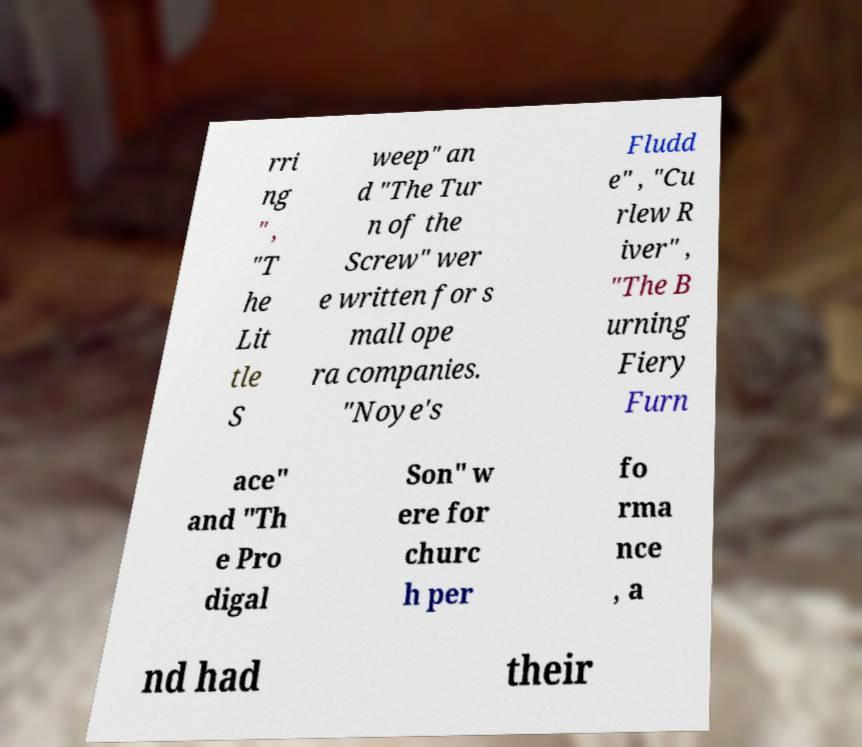What messages or text are displayed in this image? I need them in a readable, typed format. rri ng " , "T he Lit tle S weep" an d "The Tur n of the Screw" wer e written for s mall ope ra companies. "Noye's Fludd e" , "Cu rlew R iver" , "The B urning Fiery Furn ace" and "Th e Pro digal Son" w ere for churc h per fo rma nce , a nd had their 